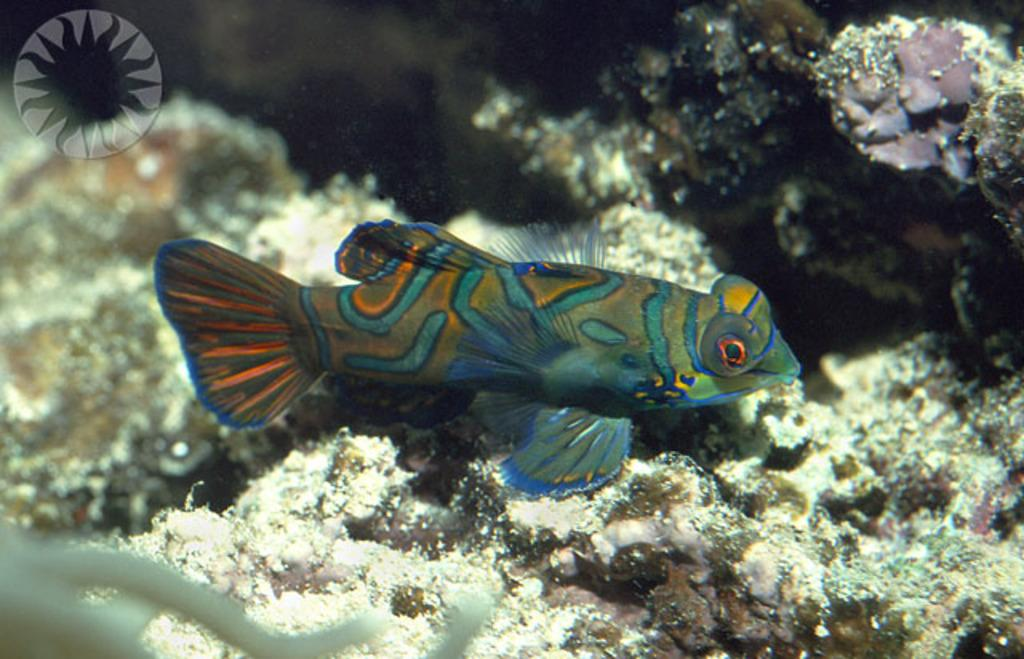What type of animal is in the image? There is a fish in the image. What can be seen behind the fish? There are objects visible behind the fish. Where is the logo located in the image? The logo is in the top left corner of the image. What is the color of the object in the bottom left corner of the image? The object in the bottom left corner of the image is white. What type of brick theory is being discussed in the image? There is no reference to a brick theory in the image; it features a fish and other elements. 